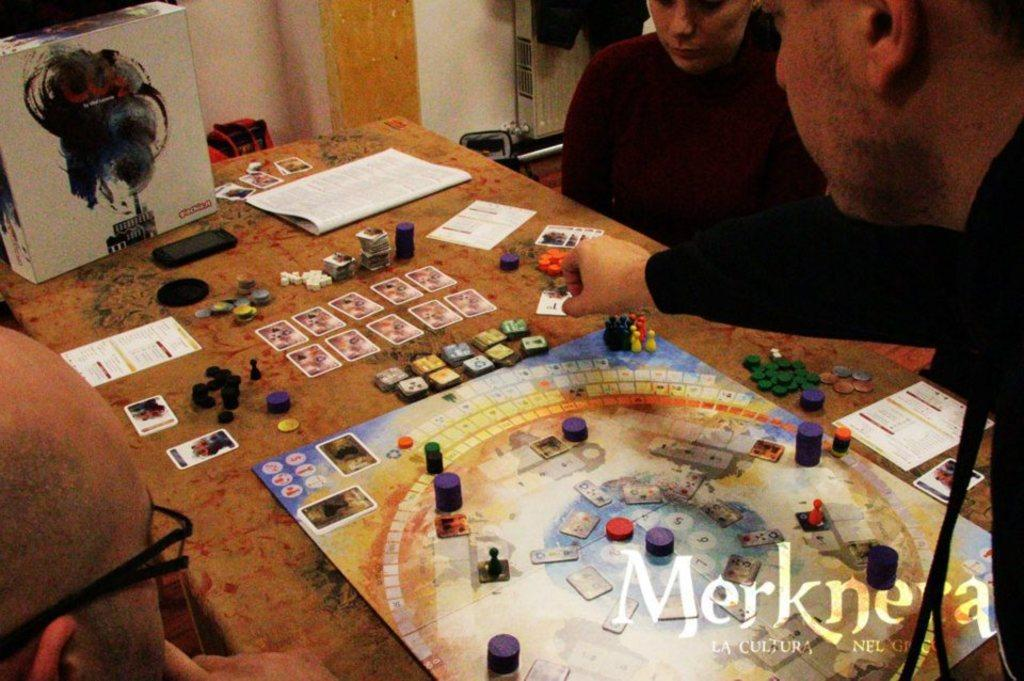How many people are in the group in the image? There is a group of people in the image, but the exact number is not specified. What are the people in the group doing in the image? The group of people is sitting in front of a table. What can be found on the table in the image? The table contains board games, books, a phone, a box, and a few other objects. Can you describe the type of games or books on the table? The facts provided do not specify the type of games or books on the table. What type of leaf is being used as a writing surface by the group in the image? There is no leaf present in the image, and the group is not using any writing surface. 